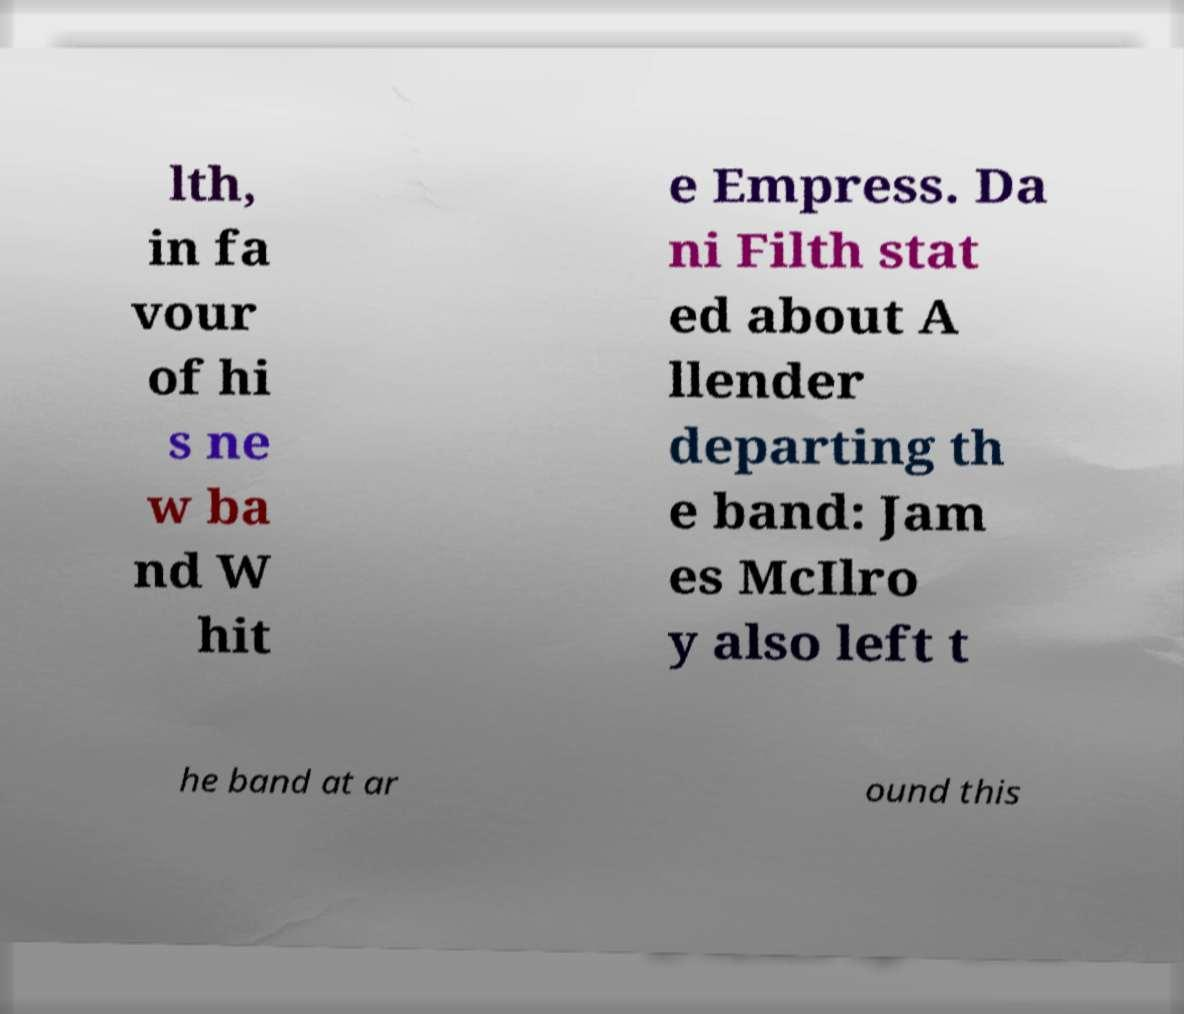Can you accurately transcribe the text from the provided image for me? lth, in fa vour of hi s ne w ba nd W hit e Empress. Da ni Filth stat ed about A llender departing th e band: Jam es McIlro y also left t he band at ar ound this 